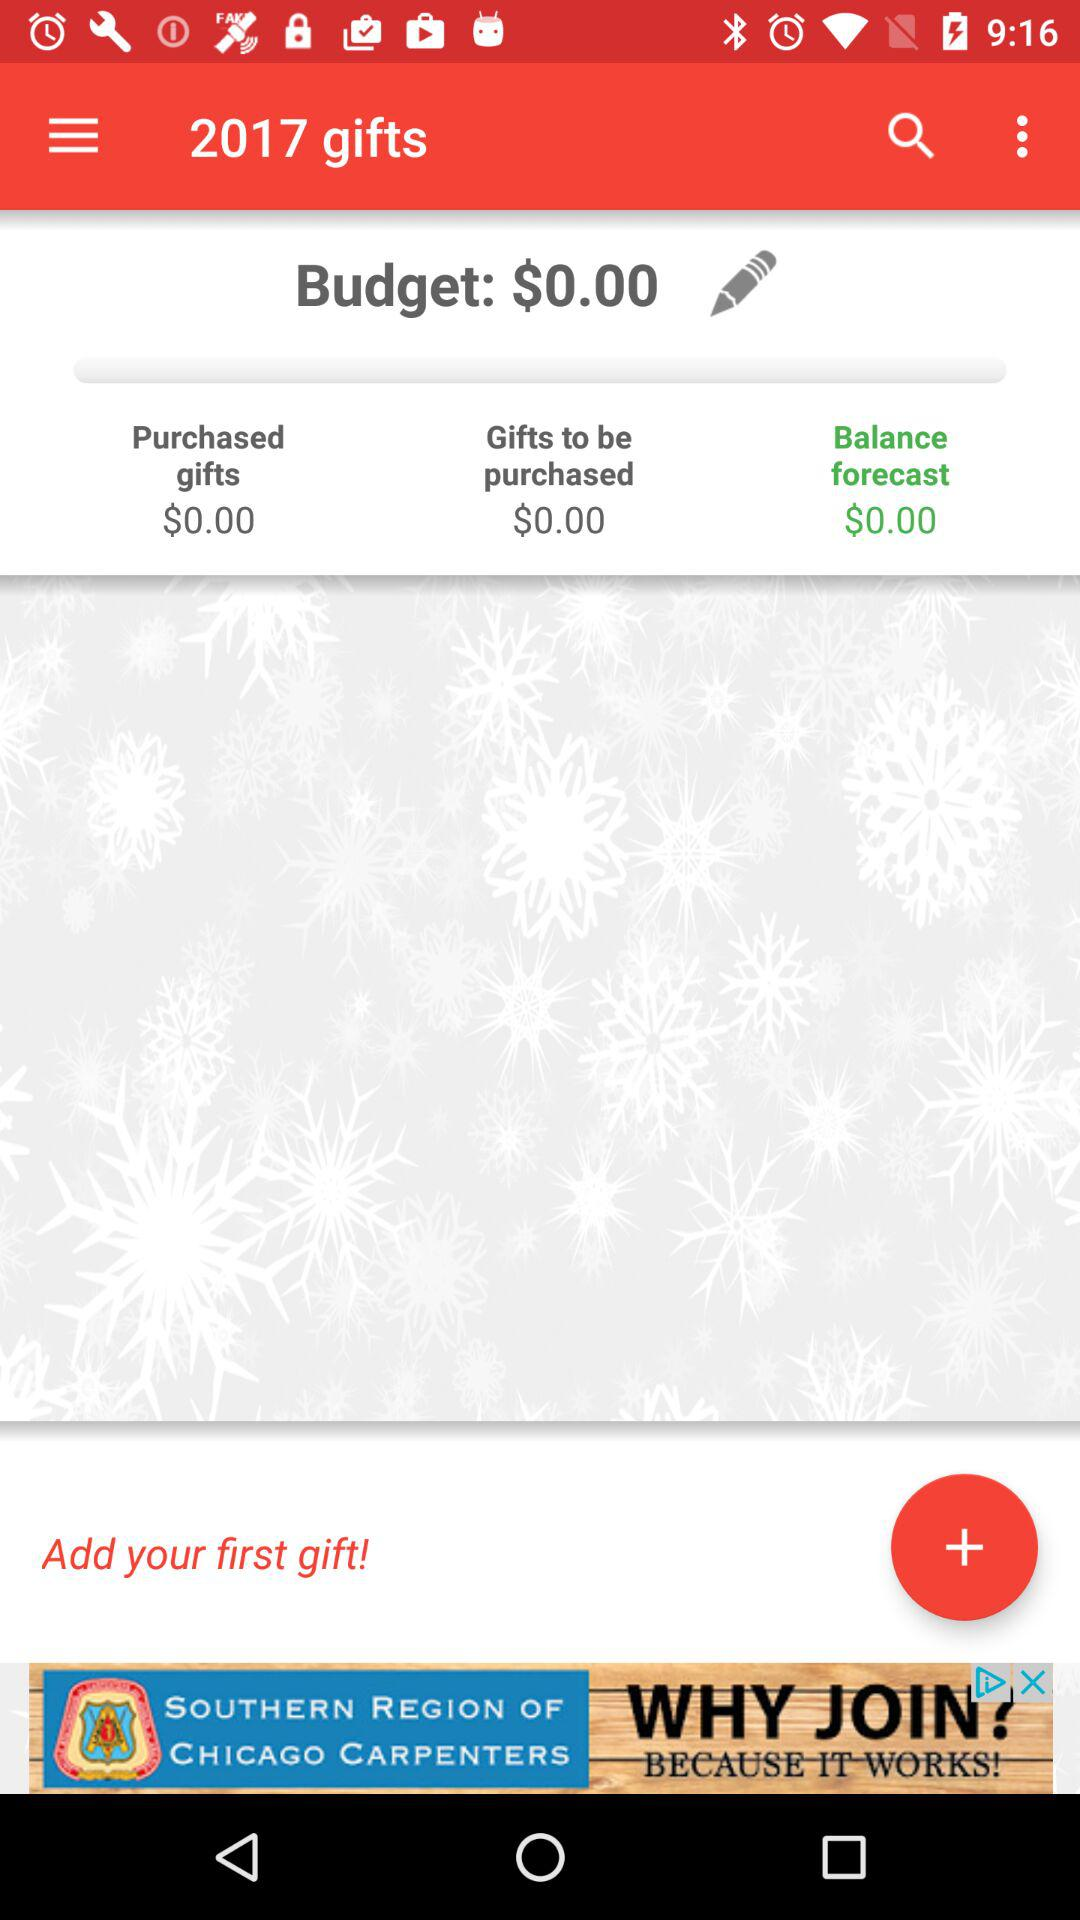How much money do I have left to spend on gifts?
Answer the question using a single word or phrase. $0.00 